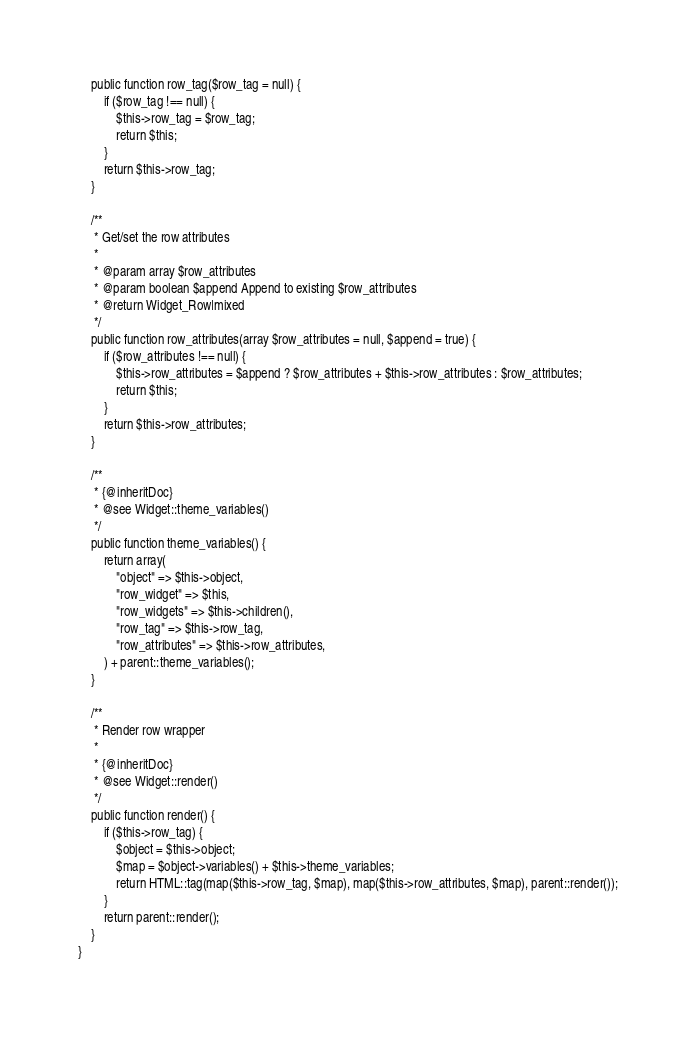<code> <loc_0><loc_0><loc_500><loc_500><_PHP_>	public function row_tag($row_tag = null) {
		if ($row_tag !== null) {
			$this->row_tag = $row_tag;
			return $this;
		}
		return $this->row_tag;
	}

	/**
	 * Get/set the row attributes
	 *
	 * @param array $row_attributes
	 * @param boolean $append Append to existing $row_attributes
	 * @return Widget_Row|mixed
	 */
	public function row_attributes(array $row_attributes = null, $append = true) {
		if ($row_attributes !== null) {
			$this->row_attributes = $append ? $row_attributes + $this->row_attributes : $row_attributes;
			return $this;
		}
		return $this->row_attributes;
	}

	/**
	 * {@inheritDoc}
	 * @see Widget::theme_variables()
	 */
	public function theme_variables() {
		return array(
			"object" => $this->object,
			"row_widget" => $this,
			"row_widgets" => $this->children(),
			"row_tag" => $this->row_tag,
			"row_attributes" => $this->row_attributes,
		) + parent::theme_variables();
	}

	/**
	 * Render row wrapper
	 *
	 * {@inheritDoc}
	 * @see Widget::render()
	 */
	public function render() {
		if ($this->row_tag) {
			$object = $this->object;
			$map = $object->variables() + $this->theme_variables;
			return HTML::tag(map($this->row_tag, $map), map($this->row_attributes, $map), parent::render());
		}
		return parent::render();
	}
}
</code> 